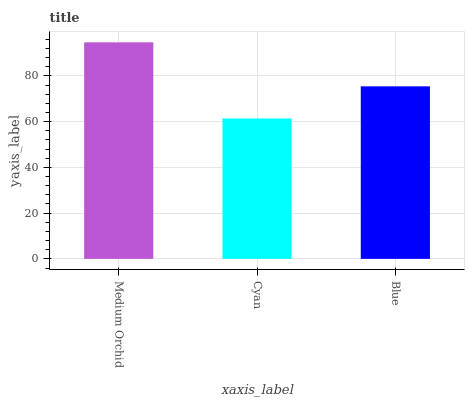Is Cyan the minimum?
Answer yes or no. Yes. Is Medium Orchid the maximum?
Answer yes or no. Yes. Is Blue the minimum?
Answer yes or no. No. Is Blue the maximum?
Answer yes or no. No. Is Blue greater than Cyan?
Answer yes or no. Yes. Is Cyan less than Blue?
Answer yes or no. Yes. Is Cyan greater than Blue?
Answer yes or no. No. Is Blue less than Cyan?
Answer yes or no. No. Is Blue the high median?
Answer yes or no. Yes. Is Blue the low median?
Answer yes or no. Yes. Is Cyan the high median?
Answer yes or no. No. Is Cyan the low median?
Answer yes or no. No. 